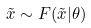Convert formula to latex. <formula><loc_0><loc_0><loc_500><loc_500>\tilde { x } \sim F ( \tilde { x } | \theta )</formula> 